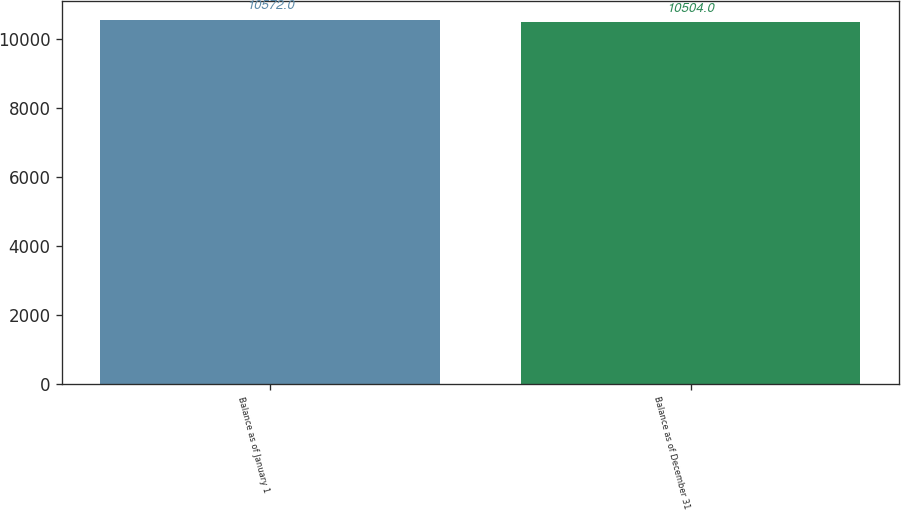Convert chart. <chart><loc_0><loc_0><loc_500><loc_500><bar_chart><fcel>Balance as of January 1<fcel>Balance as of December 31<nl><fcel>10572<fcel>10504<nl></chart> 